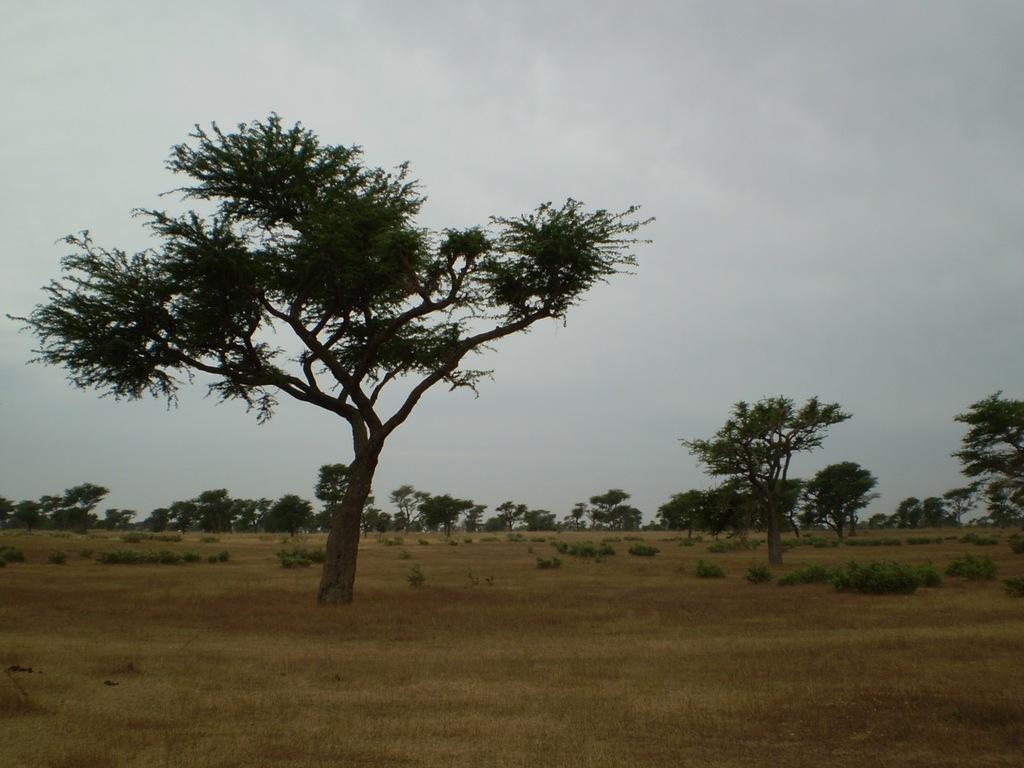In one or two sentences, can you explain what this image depicts? In this image I can see trees in an open garden. At the top of the image I can see the sky.  